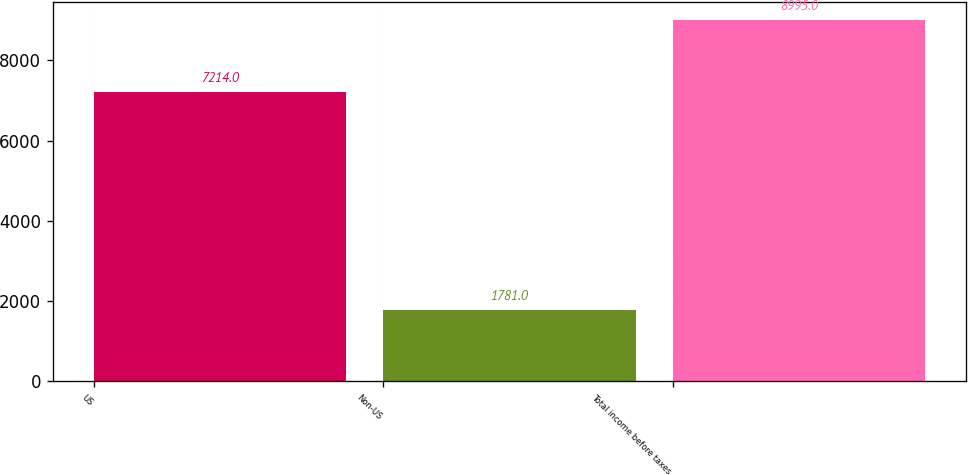<chart> <loc_0><loc_0><loc_500><loc_500><bar_chart><fcel>US<fcel>Non-US<fcel>Total income before taxes<nl><fcel>7214<fcel>1781<fcel>8995<nl></chart> 